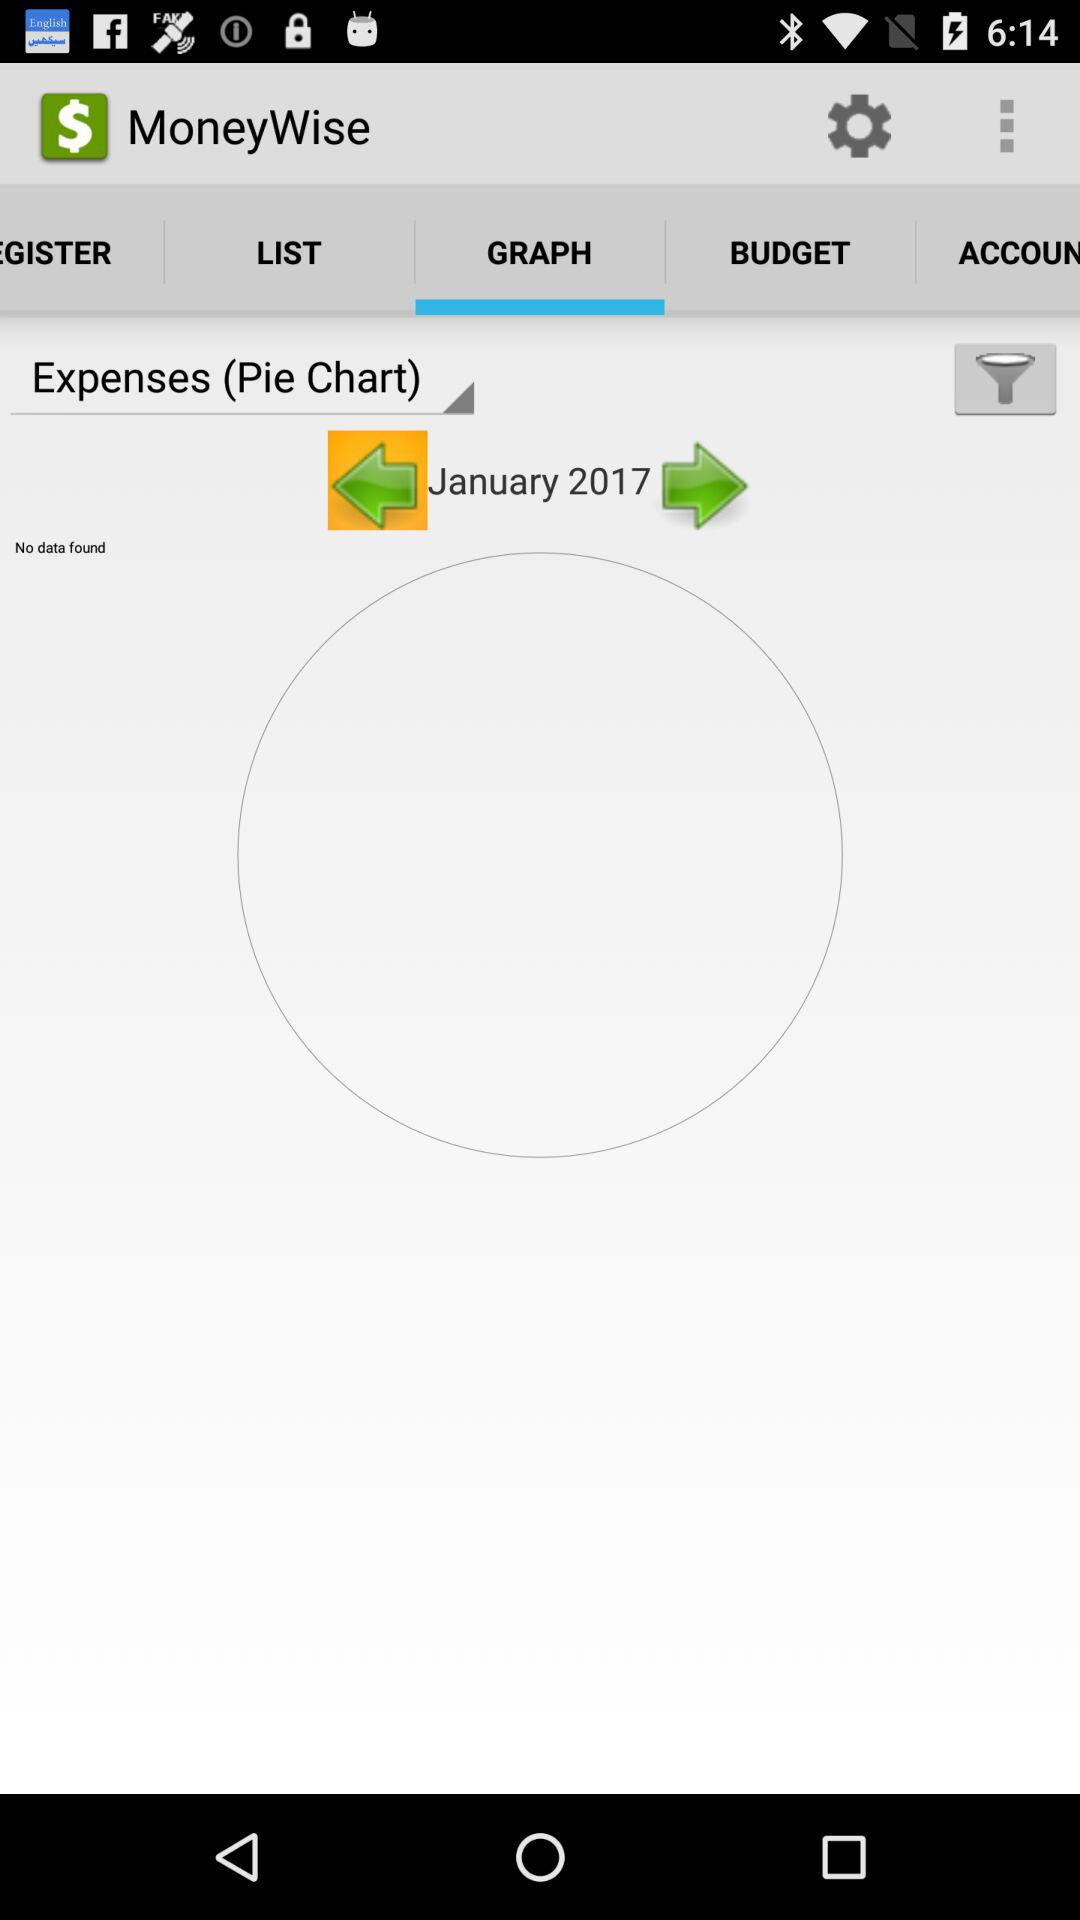What is the selected month? The selected month is "January". 